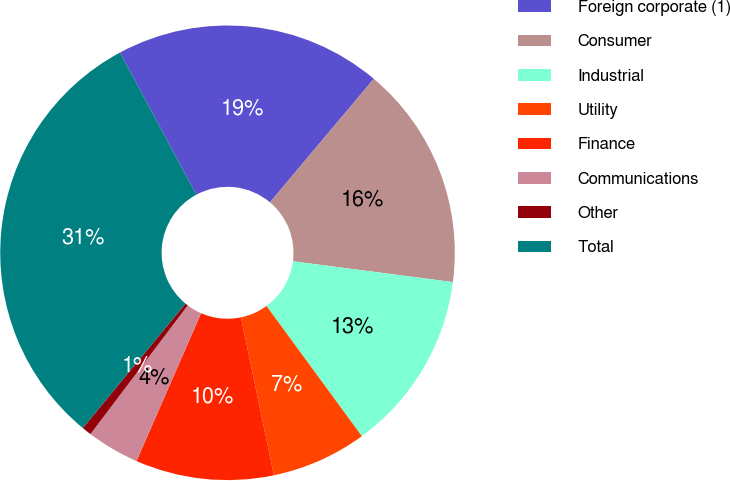Convert chart. <chart><loc_0><loc_0><loc_500><loc_500><pie_chart><fcel>Foreign corporate (1)<fcel>Consumer<fcel>Industrial<fcel>Utility<fcel>Finance<fcel>Communications<fcel>Other<fcel>Total<nl><fcel>18.97%<fcel>15.93%<fcel>12.88%<fcel>6.79%<fcel>9.83%<fcel>3.74%<fcel>0.69%<fcel>31.16%<nl></chart> 